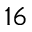<formula> <loc_0><loc_0><loc_500><loc_500>^ { 1 6 }</formula> 